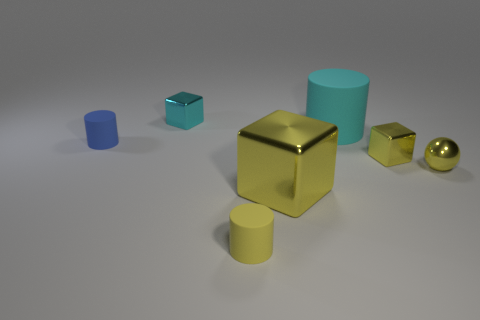Add 2 big rubber objects. How many objects exist? 9 Subtract all cubes. How many objects are left? 4 Subtract all cyan metallic cubes. Subtract all cyan metal things. How many objects are left? 5 Add 1 tiny yellow shiny balls. How many tiny yellow shiny balls are left? 2 Add 3 small spheres. How many small spheres exist? 4 Subtract 0 blue spheres. How many objects are left? 7 